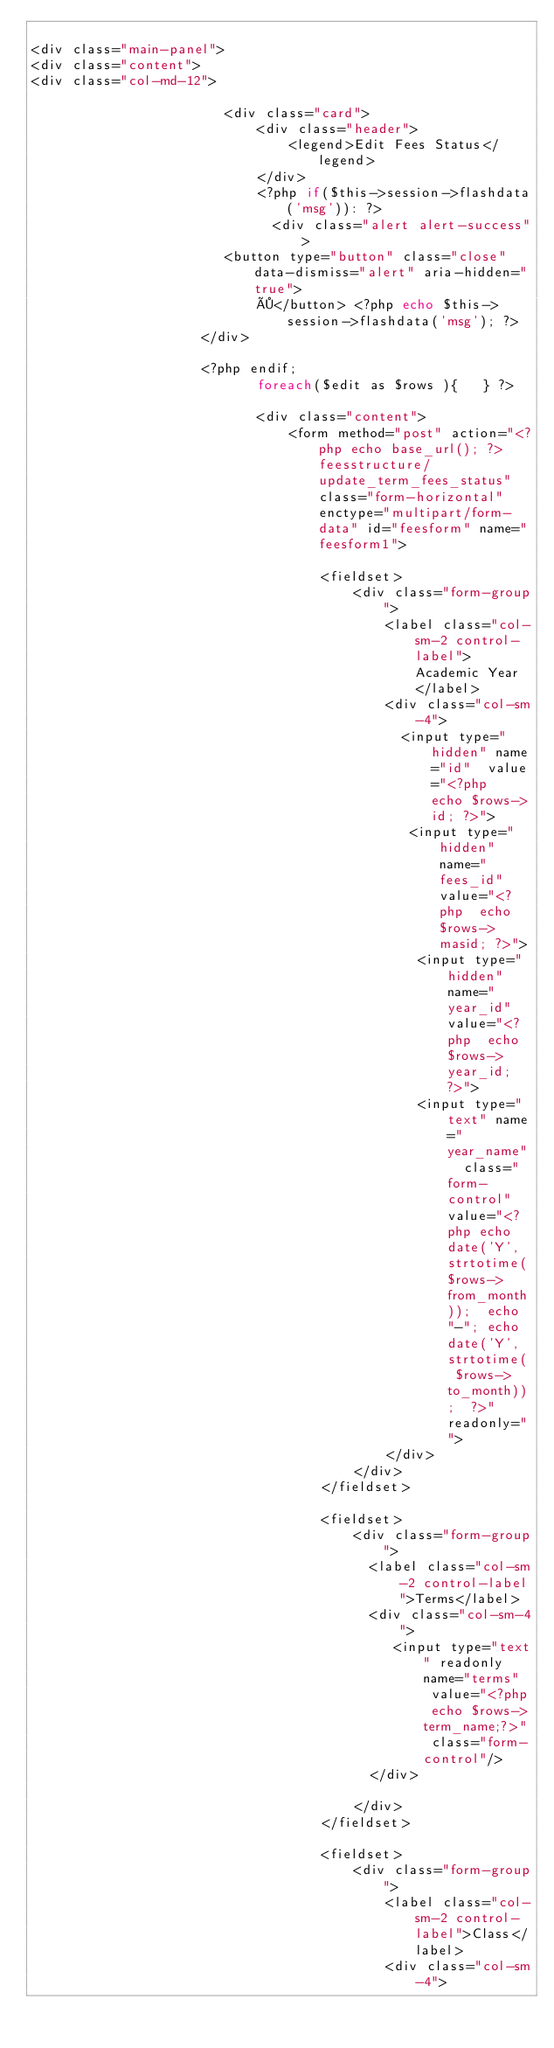<code> <loc_0><loc_0><loc_500><loc_500><_PHP_>
<div class="main-panel">
<div class="content">
<div class="col-md-12">

                        <div class="card">
                            <div class="header">
                                <legend>Edit Fees Status</legend>
                            </div>
                            <?php if($this->session->flashdata('msg')): ?>
                              <div class="alert alert-success">
                        <button type="button" class="close" data-dismiss="alert" aria-hidden="true">
                            ×</button> <?php echo $this->session->flashdata('msg'); ?>
                     </div>

                     <?php endif;
                            foreach($edit as $rows ){	} ?>

                            <div class="content">
                                <form method="post" action="<?php echo base_url(); ?>feesstructure/update_term_fees_status" class="form-horizontal" enctype="multipart/form-data" id="feesform" name="feesform1">

                                    <fieldset>
                                        <div class="form-group">
                                            <label class="col-sm-2 control-label">Academic Year</label>
                                            <div class="col-sm-4">
                                              <input type="hidden" name="id"  value="<?php  echo $rows->id; ?>">
											   <input type="hidden" name="fees_id"  value="<?php  echo $rows->masid; ?>">
                                                <input type="hidden" name="year_id"  value="<?php  echo $rows->year_id; ?>">
                                                <input type="text" name="year_name"  class="form-control" value="<?php echo date('Y', strtotime($rows->from_month));  echo "-"; echo date('Y', strtotime( $rows->to_month));  ?>" readonly="">
                                            </div>
                                        </div>
                                    </fieldset>

                                    <fieldset>
                                        <div class="form-group">
                                          <label class="col-sm-2 control-label">Terms</label>
                                          <div class="col-sm-4">
										     <input type="text" readonly name="terms"  value="<?php echo $rows->term_name;?>" class="form-control"/>
                                          </div>

                                        </div>
                                    </fieldset>

                                    <fieldset>
                                        <div class="form-group">
                                            <label class="col-sm-2 control-label">Class</label>
                                            <div class="col-sm-4"></code> 